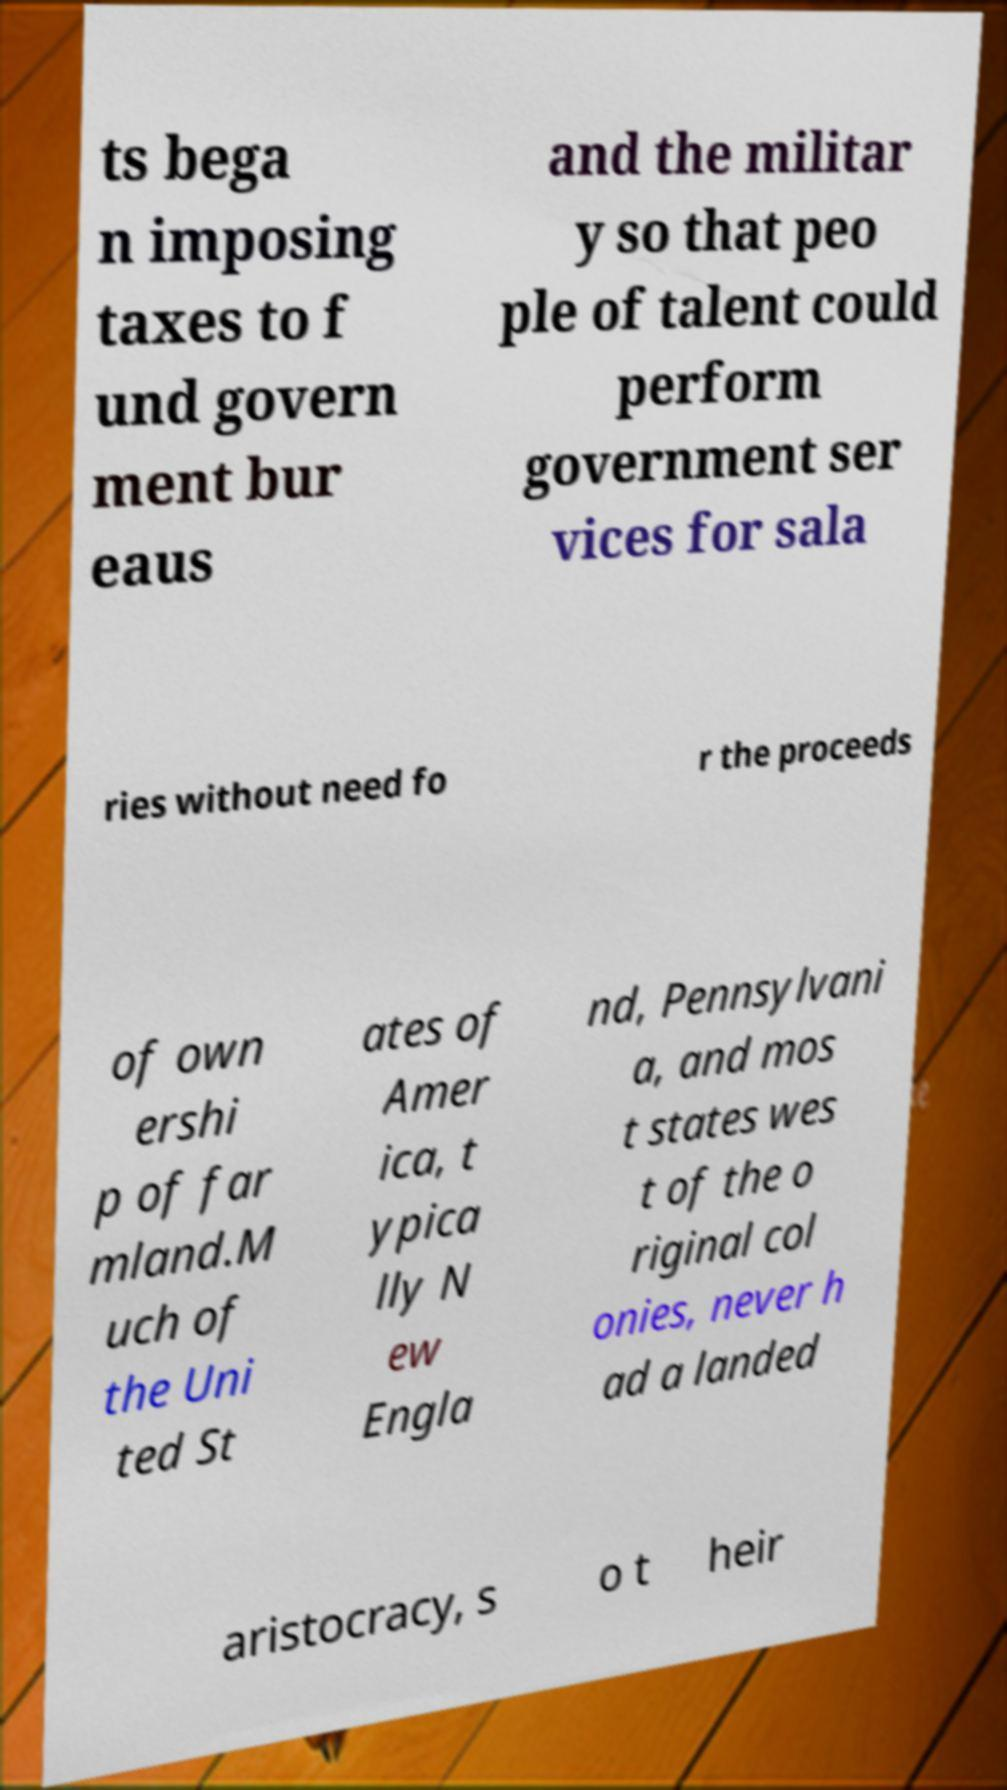Can you read and provide the text displayed in the image?This photo seems to have some interesting text. Can you extract and type it out for me? ts bega n imposing taxes to f und govern ment bur eaus and the militar y so that peo ple of talent could perform government ser vices for sala ries without need fo r the proceeds of own ershi p of far mland.M uch of the Uni ted St ates of Amer ica, t ypica lly N ew Engla nd, Pennsylvani a, and mos t states wes t of the o riginal col onies, never h ad a landed aristocracy, s o t heir 